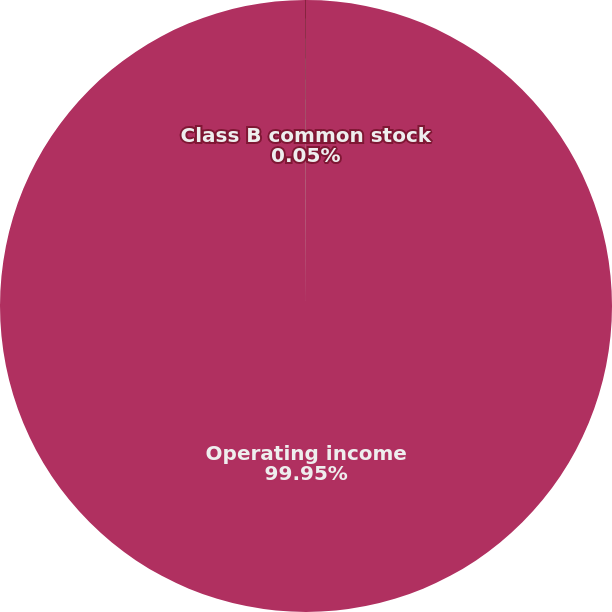<chart> <loc_0><loc_0><loc_500><loc_500><pie_chart><fcel>Operating income<fcel>Class B common stock<nl><fcel>99.95%<fcel>0.05%<nl></chart> 